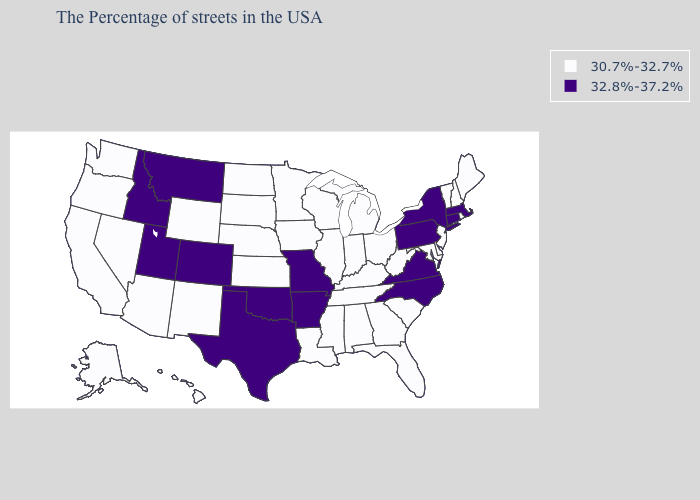What is the value of Alabama?
Answer briefly. 30.7%-32.7%. What is the highest value in states that border Idaho?
Keep it brief. 32.8%-37.2%. What is the value of Mississippi?
Answer briefly. 30.7%-32.7%. What is the value of Mississippi?
Quick response, please. 30.7%-32.7%. Name the states that have a value in the range 32.8%-37.2%?
Concise answer only. Massachusetts, Connecticut, New York, Pennsylvania, Virginia, North Carolina, Missouri, Arkansas, Oklahoma, Texas, Colorado, Utah, Montana, Idaho. Does California have the same value as Wyoming?
Quick response, please. Yes. Name the states that have a value in the range 32.8%-37.2%?
Answer briefly. Massachusetts, Connecticut, New York, Pennsylvania, Virginia, North Carolina, Missouri, Arkansas, Oklahoma, Texas, Colorado, Utah, Montana, Idaho. What is the value of Alabama?
Be succinct. 30.7%-32.7%. What is the lowest value in the MidWest?
Write a very short answer. 30.7%-32.7%. Does the first symbol in the legend represent the smallest category?
Answer briefly. Yes. What is the value of Vermont?
Quick response, please. 30.7%-32.7%. Name the states that have a value in the range 30.7%-32.7%?
Concise answer only. Maine, Rhode Island, New Hampshire, Vermont, New Jersey, Delaware, Maryland, South Carolina, West Virginia, Ohio, Florida, Georgia, Michigan, Kentucky, Indiana, Alabama, Tennessee, Wisconsin, Illinois, Mississippi, Louisiana, Minnesota, Iowa, Kansas, Nebraska, South Dakota, North Dakota, Wyoming, New Mexico, Arizona, Nevada, California, Washington, Oregon, Alaska, Hawaii. Name the states that have a value in the range 30.7%-32.7%?
Keep it brief. Maine, Rhode Island, New Hampshire, Vermont, New Jersey, Delaware, Maryland, South Carolina, West Virginia, Ohio, Florida, Georgia, Michigan, Kentucky, Indiana, Alabama, Tennessee, Wisconsin, Illinois, Mississippi, Louisiana, Minnesota, Iowa, Kansas, Nebraska, South Dakota, North Dakota, Wyoming, New Mexico, Arizona, Nevada, California, Washington, Oregon, Alaska, Hawaii. What is the lowest value in the Northeast?
Keep it brief. 30.7%-32.7%. 